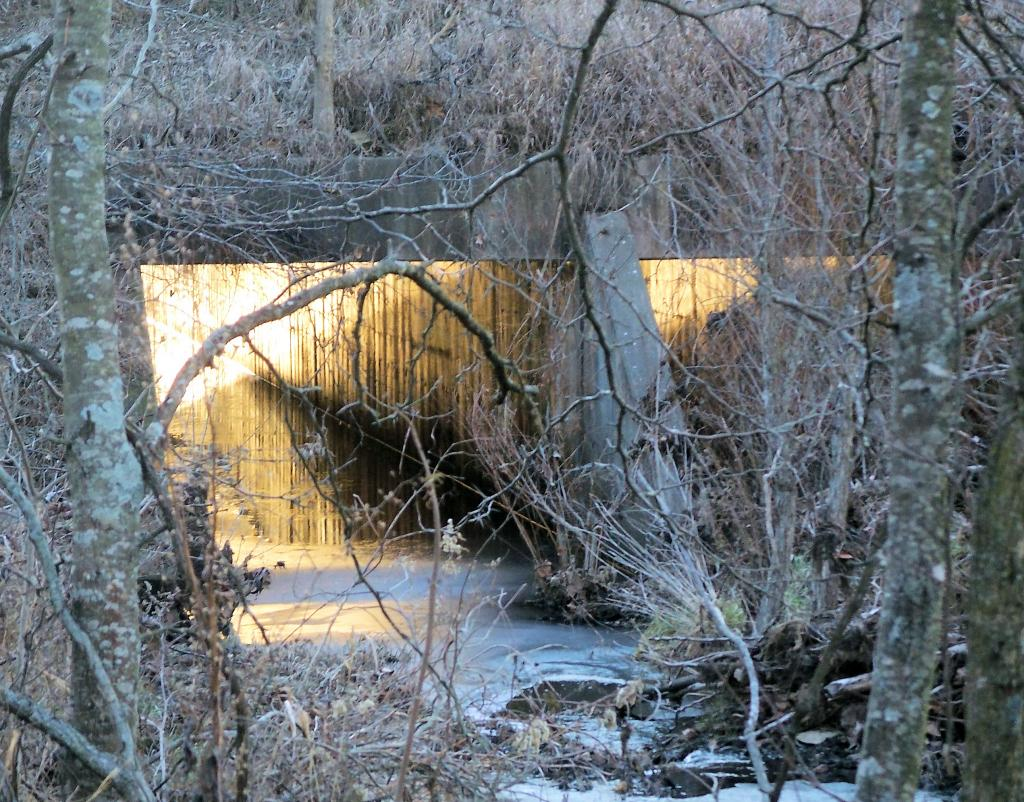What type of vegetation is visible in the image? There are bare trees in the image. What structure can be seen in the background of the image? There is a tunnel in the background of the image. What can be seen inside the tunnel? There are lights visible in the tunnel. What type of substance is dripping from the tail of the animal in the image? There is no animal or substance dripping from a tail present in the image. What type of lock is securing the tunnel in the image? There is no lock securing the tunnel in the image; it is an open tunnel with visible lights. 